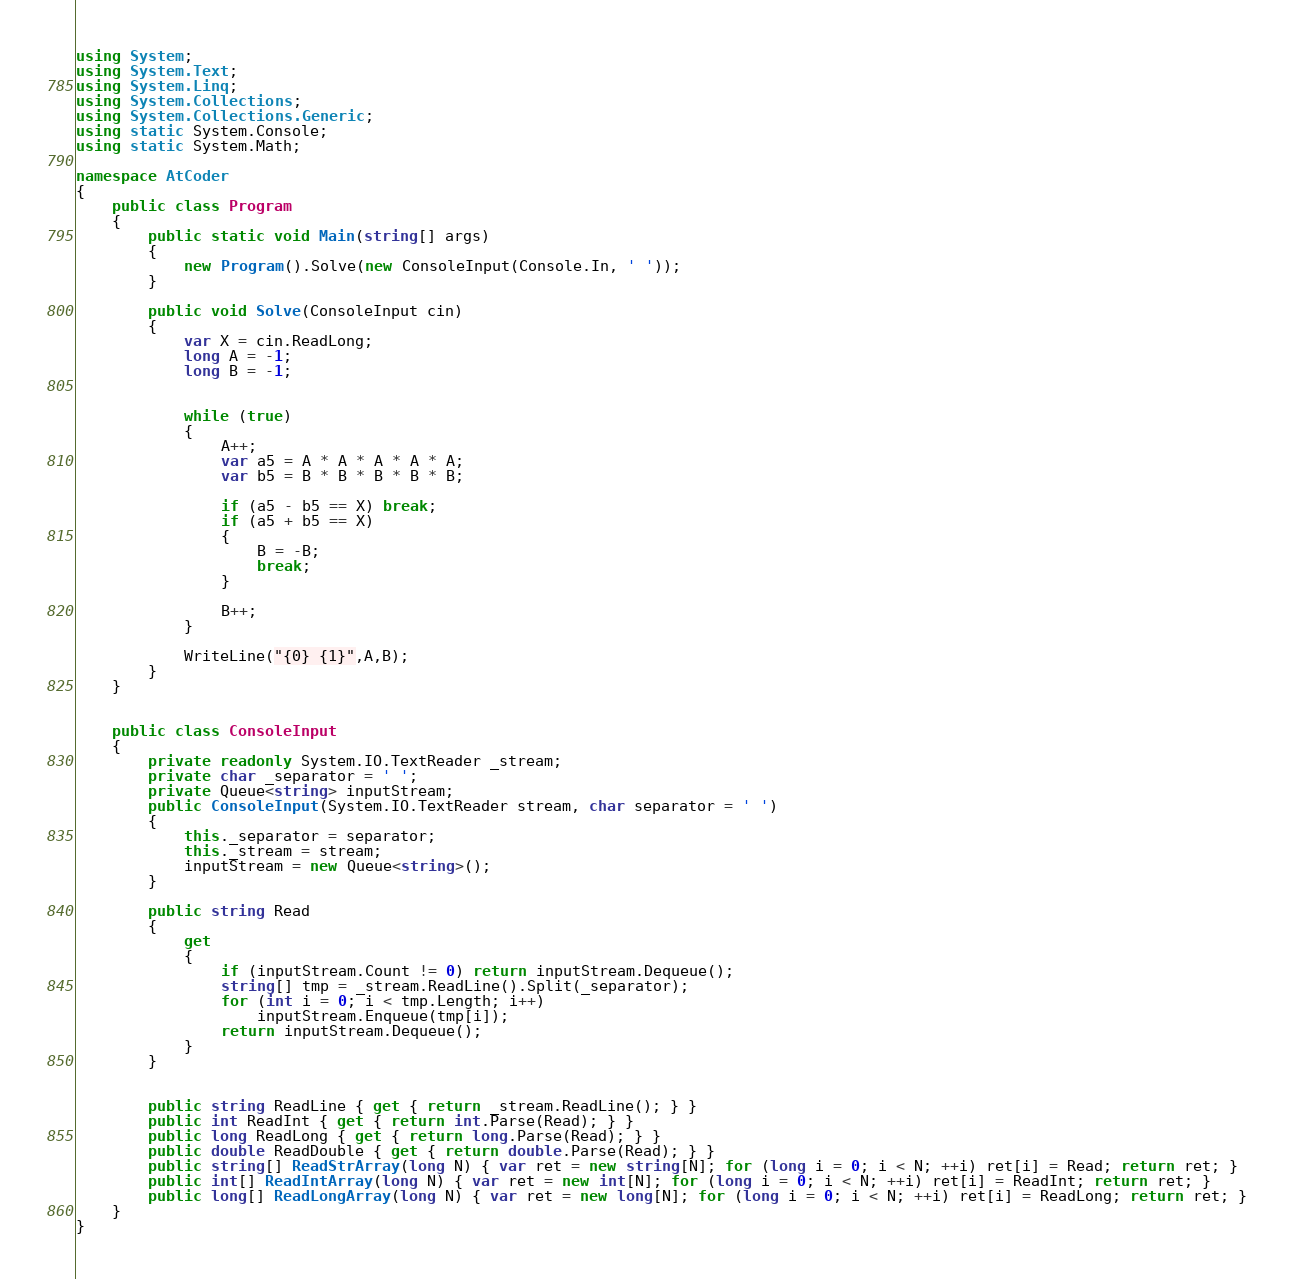Convert code to text. <code><loc_0><loc_0><loc_500><loc_500><_C#_>using System;
using System.Text;
using System.Linq;
using System.Collections;
using System.Collections.Generic;
using static System.Console;
using static System.Math;

namespace AtCoder
{
    public class Program
    {
        public static void Main(string[] args)
        {
            new Program().Solve(new ConsoleInput(Console.In, ' '));
        }

        public void Solve(ConsoleInput cin)
        {
            var X = cin.ReadLong;
            long A = -1;
            long B = -1;


            while (true)
            {
                A++;
                var a5 = A * A * A * A * A;
                var b5 = B * B * B * B * B;

                if (a5 - b5 == X) break;
                if (a5 + b5 == X)
                {
                    B = -B;
                    break;
                }

                B++;
            }

            WriteLine("{0} {1}",A,B);
        }
    }


    public class ConsoleInput
    {
        private readonly System.IO.TextReader _stream;
        private char _separator = ' ';
        private Queue<string> inputStream;
        public ConsoleInput(System.IO.TextReader stream, char separator = ' ')
        {
            this._separator = separator;
            this._stream = stream;
            inputStream = new Queue<string>();
        }

        public string Read
        {
            get
            {
                if (inputStream.Count != 0) return inputStream.Dequeue();
                string[] tmp = _stream.ReadLine().Split(_separator);
                for (int i = 0; i < tmp.Length; i++)
                    inputStream.Enqueue(tmp[i]);
                return inputStream.Dequeue();
            }
        }


        public string ReadLine { get { return _stream.ReadLine(); } }
        public int ReadInt { get { return int.Parse(Read); } }
        public long ReadLong { get { return long.Parse(Read); } }
        public double ReadDouble { get { return double.Parse(Read); } }
        public string[] ReadStrArray(long N) { var ret = new string[N]; for (long i = 0; i < N; ++i) ret[i] = Read; return ret; }
        public int[] ReadIntArray(long N) { var ret = new int[N]; for (long i = 0; i < N; ++i) ret[i] = ReadInt; return ret; }
        public long[] ReadLongArray(long N) { var ret = new long[N]; for (long i = 0; i < N; ++i) ret[i] = ReadLong; return ret; }
    }
}
</code> 